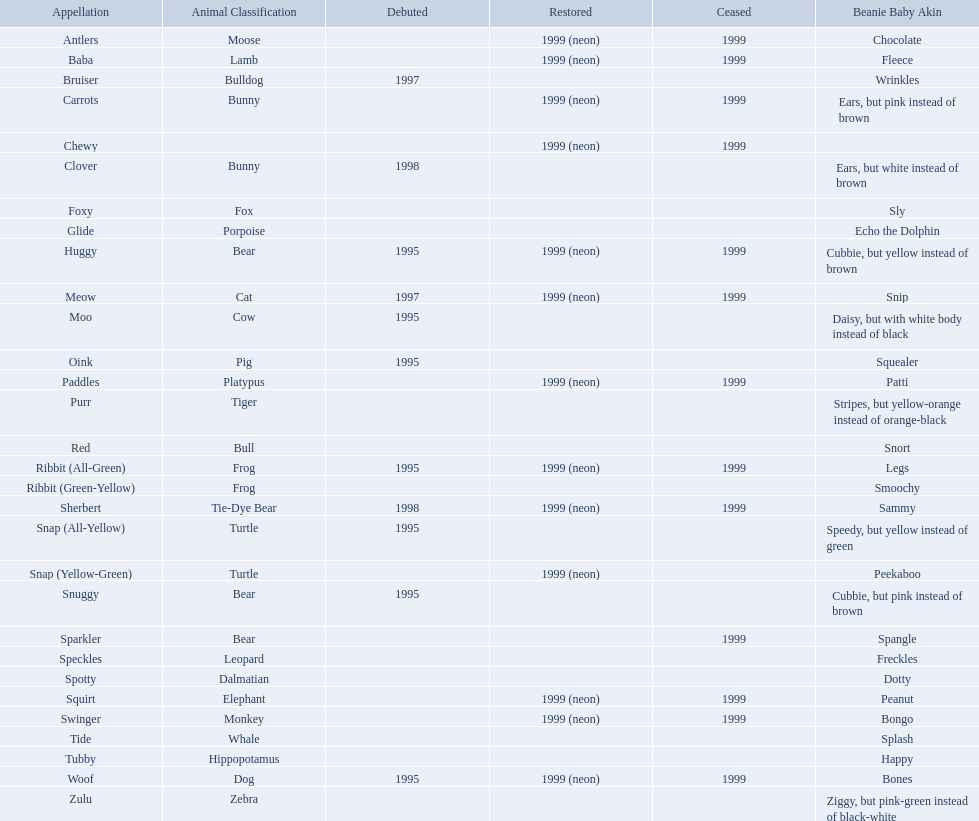What are the types of pillow pal animals? Antlers, Moose, Lamb, Bulldog, Bunny, , Bunny, Fox, Porpoise, Bear, Cat, Cow, Pig, Platypus, Tiger, Bull, Frog, Frog, Tie-Dye Bear, Turtle, Turtle, Bear, Bear, Leopard, Dalmatian, Elephant, Monkey, Whale, Hippopotamus, Dog, Zebra. Of those, which is a dalmatian? Dalmatian. What is the name of the dalmatian? Spotty. What are all the different names of the pillow pals? Antlers, Baba, Bruiser, Carrots, Chewy, Clover, Foxy, Glide, Huggy, Meow, Moo, Oink, Paddles, Purr, Red, Ribbit (All-Green), Ribbit (Green-Yellow), Sherbert, Snap (All-Yellow), Snap (Yellow-Green), Snuggy, Sparkler, Speckles, Spotty, Squirt, Swinger, Tide, Tubby, Woof, Zulu. Which of these are a dalmatian? Spotty. What animals are pillow pals? Moose, Lamb, Bulldog, Bunny, Bunny, Fox, Porpoise, Bear, Cat, Cow, Pig, Platypus, Tiger, Bull, Frog, Frog, Tie-Dye Bear, Turtle, Turtle, Bear, Bear, Leopard, Dalmatian, Elephant, Monkey, Whale, Hippopotamus, Dog, Zebra. What is the name of the dalmatian? Spotty. What are the names listed? Antlers, Baba, Bruiser, Carrots, Chewy, Clover, Foxy, Glide, Huggy, Meow, Moo, Oink, Paddles, Purr, Red, Ribbit (All-Green), Ribbit (Green-Yellow), Sherbert, Snap (All-Yellow), Snap (Yellow-Green), Snuggy, Sparkler, Speckles, Spotty, Squirt, Swinger, Tide, Tubby, Woof, Zulu. Of these, which is the only pet without an animal type listed? Chewy. 